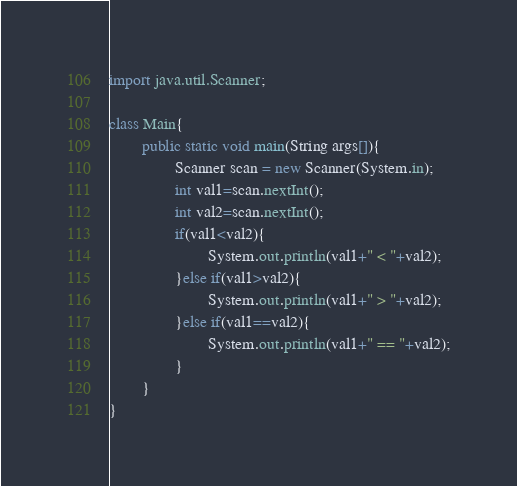Convert code to text. <code><loc_0><loc_0><loc_500><loc_500><_Java_>import java.util.Scanner;

class Main{
        public static void main(String args[]){
                Scanner scan = new Scanner(System.in);
                int val1=scan.nextInt();
                int val2=scan.nextInt();
                if(val1<val2){
                        System.out.println(val1+" < "+val2);
                }else if(val1>val2){
                        System.out.println(val1+" > "+val2);
                }else if(val1==val2){
                        System.out.println(val1+" == "+val2);
                }
        }
}</code> 